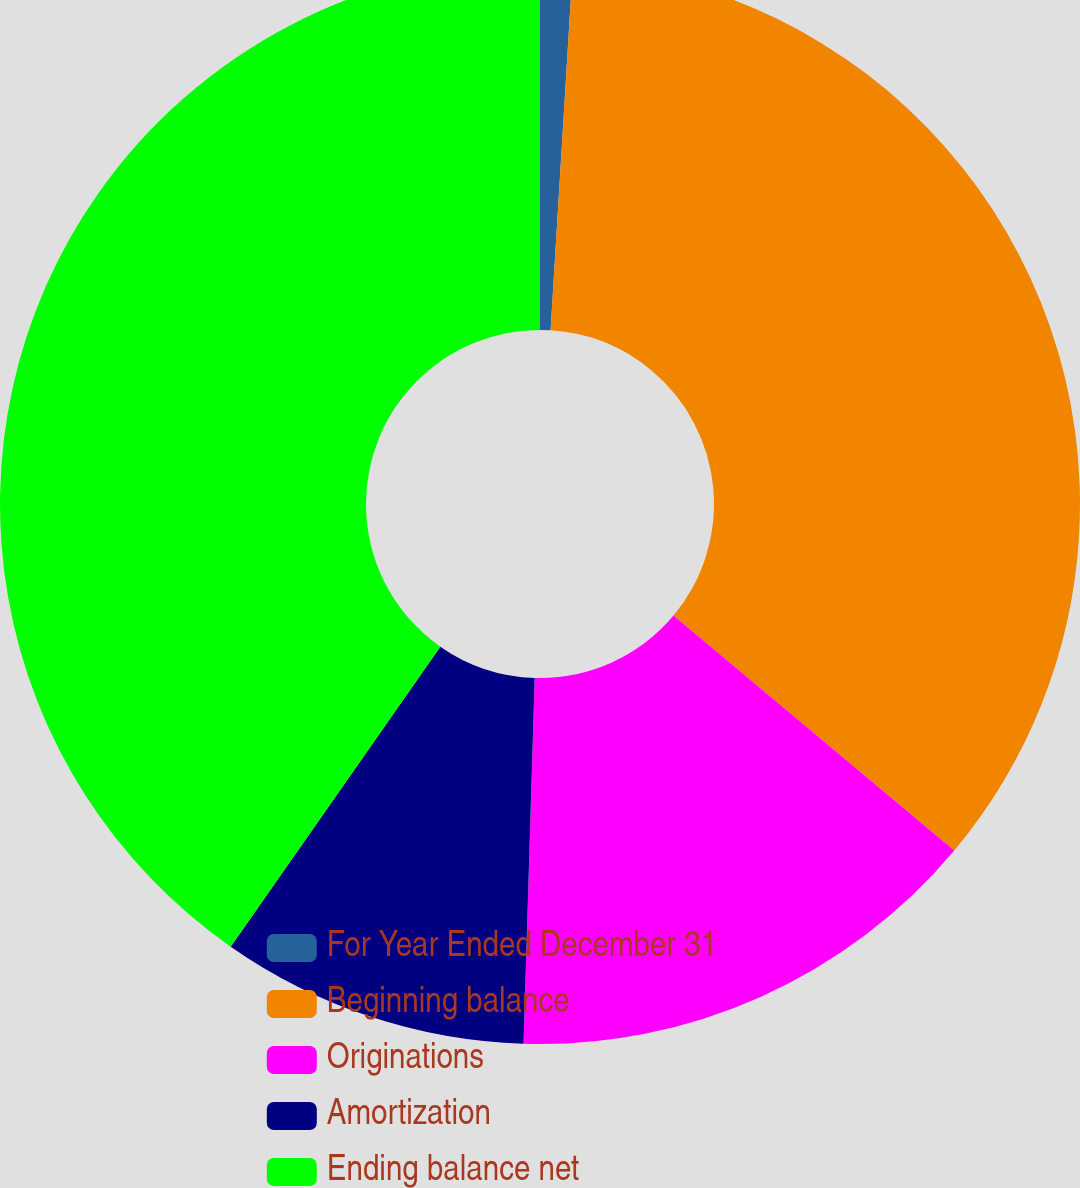<chart> <loc_0><loc_0><loc_500><loc_500><pie_chart><fcel>For Year Ended December 31<fcel>Beginning balance<fcel>Originations<fcel>Amortization<fcel>Ending balance net<nl><fcel>0.97%<fcel>35.11%<fcel>14.4%<fcel>9.22%<fcel>40.29%<nl></chart> 